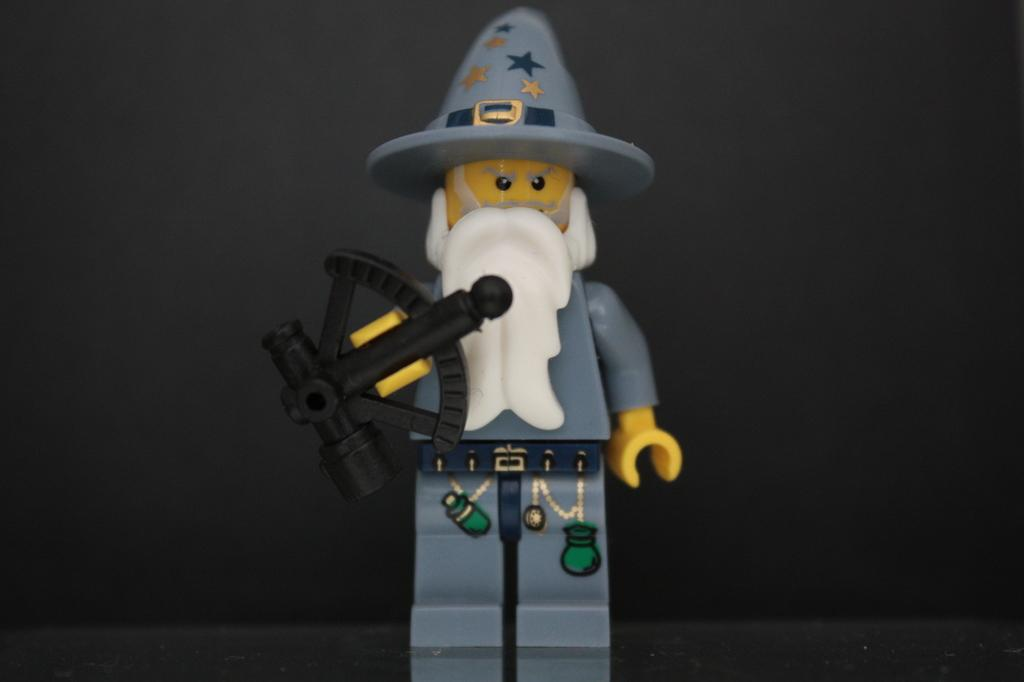What object can be seen in the image? There is a toy in the image. How many jellyfish are hiding in the bushes in the image? There are no jellyfish or bushes present in the image; it features a toy. 